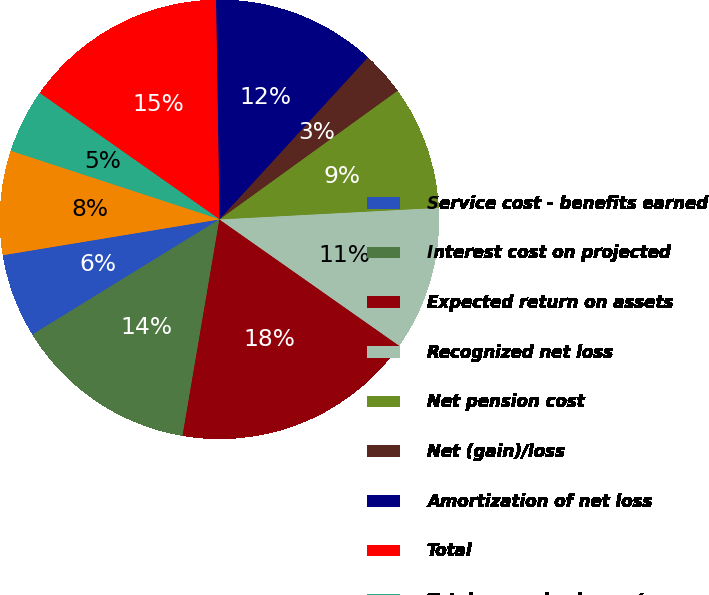Convert chart to OTSL. <chart><loc_0><loc_0><loc_500><loc_500><pie_chart><fcel>Service cost - benefits earned<fcel>Interest cost on projected<fcel>Expected return on assets<fcel>Recognized net loss<fcel>Net pension cost<fcel>Net (gain)/loss<fcel>Amortization of net loss<fcel>Total<fcel>Total recognized as net<fcel>Net loss<nl><fcel>6.18%<fcel>13.53%<fcel>17.94%<fcel>10.59%<fcel>9.12%<fcel>3.24%<fcel>12.06%<fcel>15.0%<fcel>4.71%<fcel>7.65%<nl></chart> 